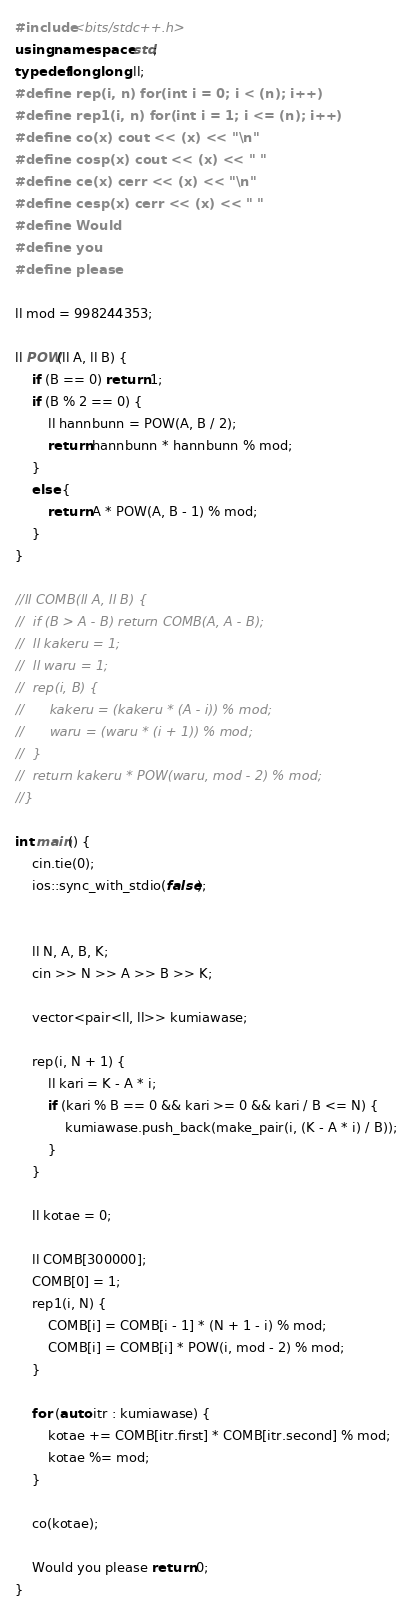<code> <loc_0><loc_0><loc_500><loc_500><_C++_>#include<bits/stdc++.h>
using namespace std;
typedef long long ll;
#define rep(i, n) for(int i = 0; i < (n); i++)
#define rep1(i, n) for(int i = 1; i <= (n); i++)
#define co(x) cout << (x) << "\n"
#define cosp(x) cout << (x) << " "
#define ce(x) cerr << (x) << "\n"
#define cesp(x) cerr << (x) << " "
#define Would
#define you
#define please

ll mod = 998244353;

ll POW(ll A, ll B) {
	if (B == 0) return 1;
	if (B % 2 == 0) {
		ll hannbunn = POW(A, B / 2);
		return hannbunn * hannbunn % mod;
	}
	else {
		return A * POW(A, B - 1) % mod;
	}
}

//ll COMB(ll A, ll B) {
//	if (B > A - B) return COMB(A, A - B);
//	ll kakeru = 1;
//	ll waru = 1;
//	rep(i, B) {
//		kakeru = (kakeru * (A - i)) % mod;
//		waru = (waru * (i + 1)) % mod;
//	}
//	return kakeru * POW(waru, mod - 2) % mod;
//}

int main() {
	cin.tie(0);
	ios::sync_with_stdio(false);


	ll N, A, B, K;
	cin >> N >> A >> B >> K;

	vector<pair<ll, ll>> kumiawase;

	rep(i, N + 1) {
		ll kari = K - A * i;
		if (kari % B == 0 && kari >= 0 && kari / B <= N) {
			kumiawase.push_back(make_pair(i, (K - A * i) / B));
		}
	}

	ll kotae = 0;

	ll COMB[300000];
	COMB[0] = 1;
	rep1(i, N) {
		COMB[i] = COMB[i - 1] * (N + 1 - i) % mod;
		COMB[i] = COMB[i] * POW(i, mod - 2) % mod;
	}

	for (auto itr : kumiawase) {
		kotae += COMB[itr.first] * COMB[itr.second] % mod;
		kotae %= mod;
	}

	co(kotae);

	Would you please return 0;
}</code> 